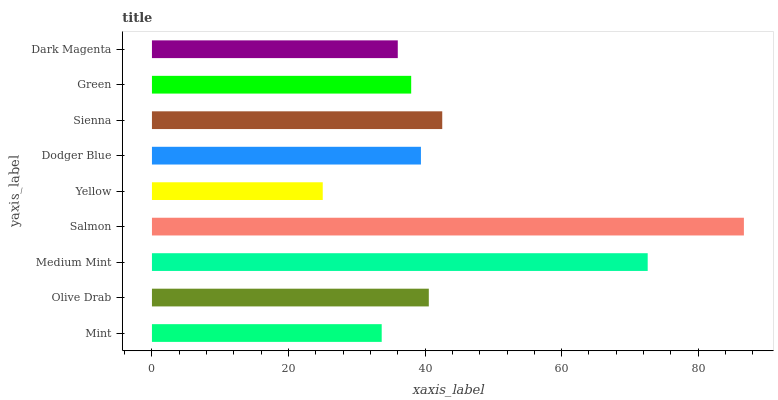Is Yellow the minimum?
Answer yes or no. Yes. Is Salmon the maximum?
Answer yes or no. Yes. Is Olive Drab the minimum?
Answer yes or no. No. Is Olive Drab the maximum?
Answer yes or no. No. Is Olive Drab greater than Mint?
Answer yes or no. Yes. Is Mint less than Olive Drab?
Answer yes or no. Yes. Is Mint greater than Olive Drab?
Answer yes or no. No. Is Olive Drab less than Mint?
Answer yes or no. No. Is Dodger Blue the high median?
Answer yes or no. Yes. Is Dodger Blue the low median?
Answer yes or no. Yes. Is Medium Mint the high median?
Answer yes or no. No. Is Olive Drab the low median?
Answer yes or no. No. 